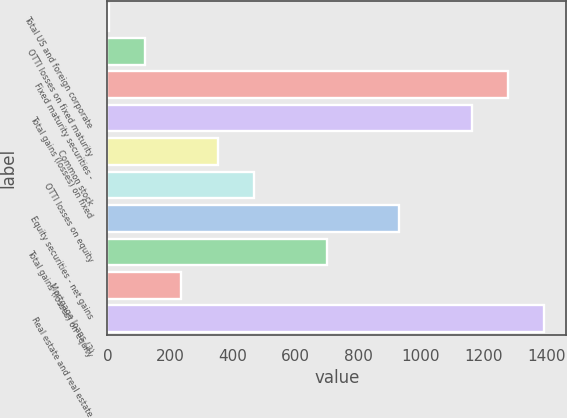Convert chart. <chart><loc_0><loc_0><loc_500><loc_500><bar_chart><fcel>Total US and foreign corporate<fcel>OTTI losses on fixed maturity<fcel>Fixed maturity securities -<fcel>Total gains (losses) on fixed<fcel>Common stock<fcel>OTTI losses on equity<fcel>Equity securities - net gains<fcel>Total gains (losses) on equity<fcel>Mortgage loans (2)<fcel>Real estate and real estate<nl><fcel>4<fcel>119.8<fcel>1277.8<fcel>1162<fcel>351.4<fcel>467.2<fcel>930.4<fcel>698.8<fcel>235.6<fcel>1393.6<nl></chart> 